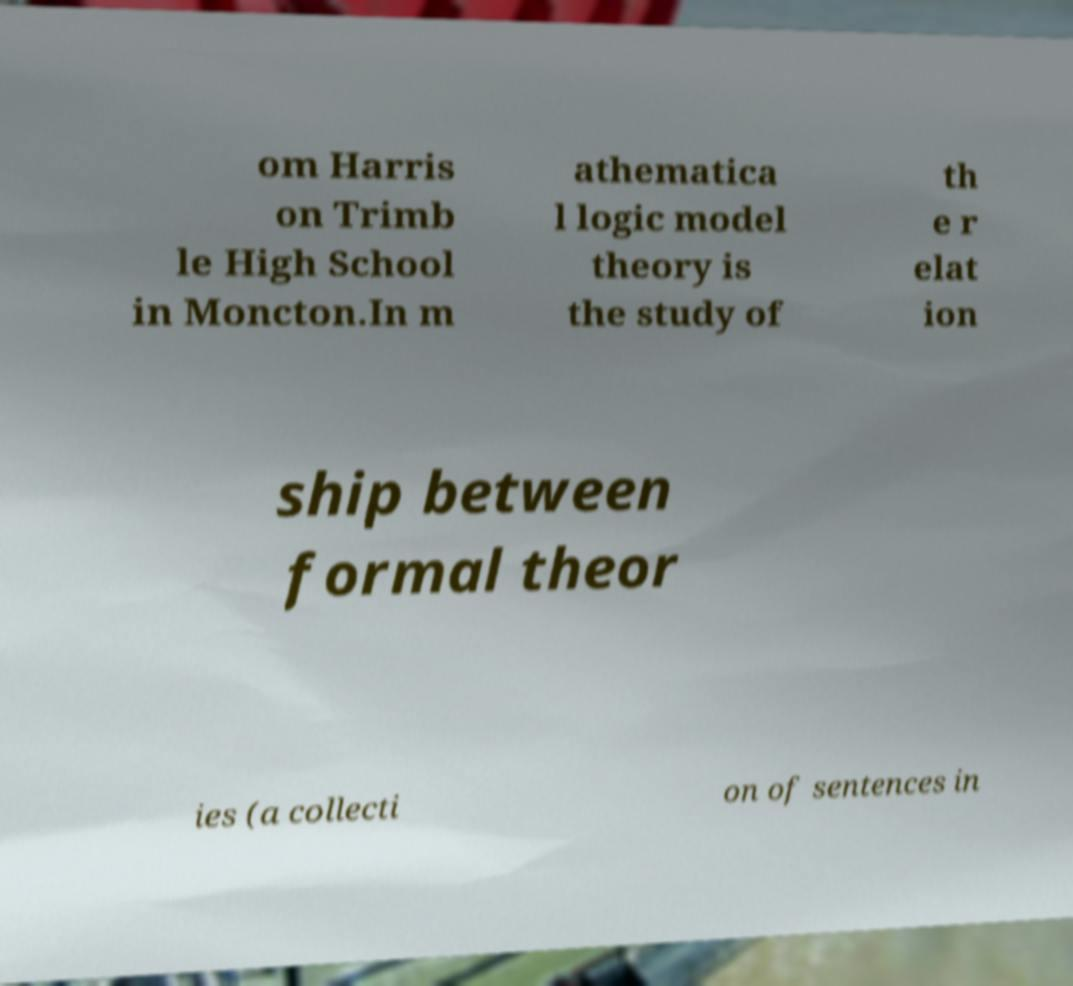There's text embedded in this image that I need extracted. Can you transcribe it verbatim? om Harris on Trimb le High School in Moncton.In m athematica l logic model theory is the study of th e r elat ion ship between formal theor ies (a collecti on of sentences in 